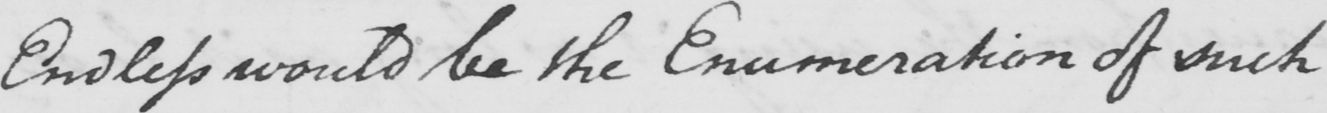Can you read and transcribe this handwriting? Endless would be the Enumeration of such 